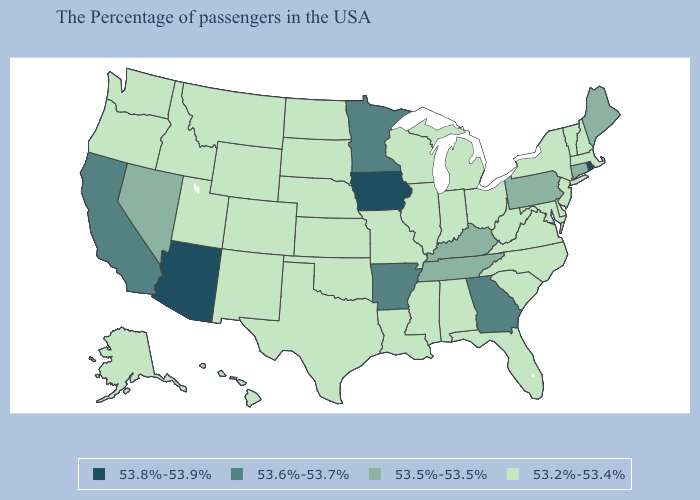Name the states that have a value in the range 53.8%-53.9%?
Concise answer only. Rhode Island, Iowa, Arizona. Among the states that border Kentucky , does West Virginia have the lowest value?
Write a very short answer. Yes. What is the lowest value in states that border Arizona?
Short answer required. 53.2%-53.4%. Among the states that border Michigan , which have the lowest value?
Short answer required. Ohio, Indiana, Wisconsin. What is the value of Kansas?
Answer briefly. 53.2%-53.4%. What is the value of Iowa?
Concise answer only. 53.8%-53.9%. Among the states that border Delaware , does New Jersey have the highest value?
Write a very short answer. No. What is the value of Virginia?
Short answer required. 53.2%-53.4%. What is the value of Tennessee?
Be succinct. 53.5%-53.5%. Does Kentucky have a higher value than Minnesota?
Concise answer only. No. Name the states that have a value in the range 53.8%-53.9%?
Short answer required. Rhode Island, Iowa, Arizona. Does North Carolina have the lowest value in the South?
Short answer required. Yes. Does Maine have the same value as Mississippi?
Give a very brief answer. No. Among the states that border Texas , which have the highest value?
Concise answer only. Arkansas. Does Mississippi have the lowest value in the USA?
Write a very short answer. Yes. 